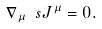<formula> <loc_0><loc_0><loc_500><loc_500>\nabla _ { \mu } \ s J ^ { \mu } = 0 .</formula> 